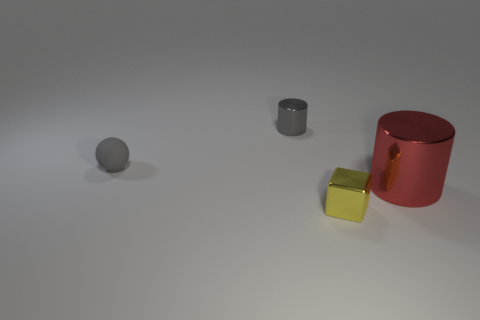How many other things have the same color as the tiny matte object?
Offer a very short reply. 1. Is the shape of the tiny gray metallic object the same as the small yellow thing?
Your answer should be very brief. No. Are there any other things that are the same size as the red object?
Make the answer very short. No. There is another object that is the same shape as the tiny gray metallic object; what size is it?
Provide a succinct answer. Large. Is the number of gray cylinders that are behind the ball greater than the number of gray things behind the tiny yellow object?
Offer a very short reply. No. Is the large red thing made of the same material as the thing in front of the red shiny thing?
Make the answer very short. Yes. Is there any other thing that is the same shape as the small gray matte thing?
Offer a terse response. No. What color is the tiny thing that is behind the small shiny block and right of the tiny matte ball?
Offer a terse response. Gray. There is a tiny object in front of the red object; what is its shape?
Your answer should be compact. Cube. How big is the block to the right of the small gray thing that is in front of the cylinder that is behind the red metallic cylinder?
Ensure brevity in your answer.  Small. 